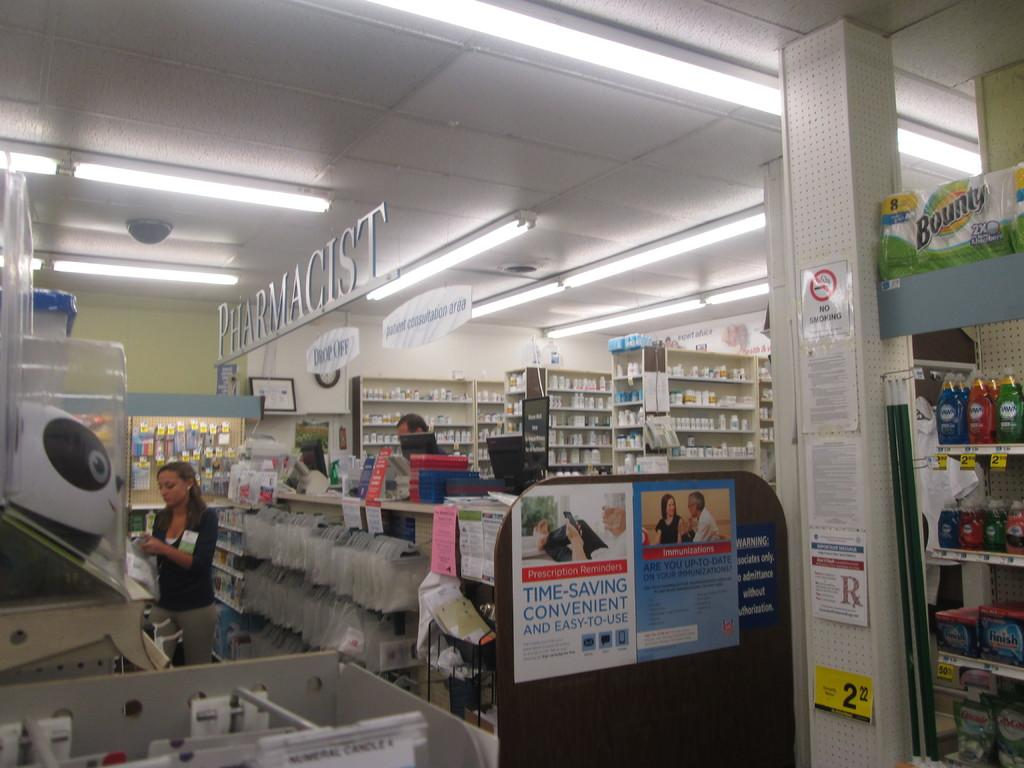<image>
Render a clear and concise summary of the photo. A yellow price tag for 2.22 sits in the Pharmacist area of the store 